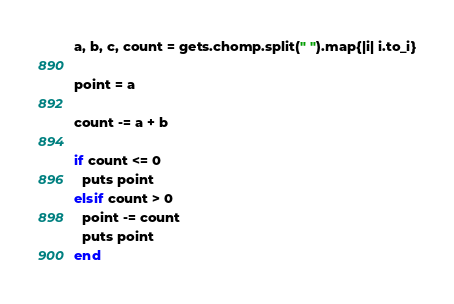<code> <loc_0><loc_0><loc_500><loc_500><_Ruby_>a, b, c, count = gets.chomp.split(" ").map{|i| i.to_i}

point = a

count -= a + b

if count <= 0
  puts point
elsif count > 0
  point -= count
  puts point
end
</code> 